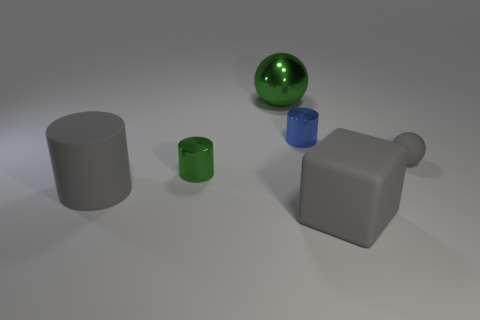Add 1 balls. How many objects exist? 7 Subtract all balls. How many objects are left? 4 Add 3 large objects. How many large objects are left? 6 Add 3 big rubber cylinders. How many big rubber cylinders exist? 4 Subtract 0 brown balls. How many objects are left? 6 Subtract all tiny blue cylinders. Subtract all large rubber objects. How many objects are left? 3 